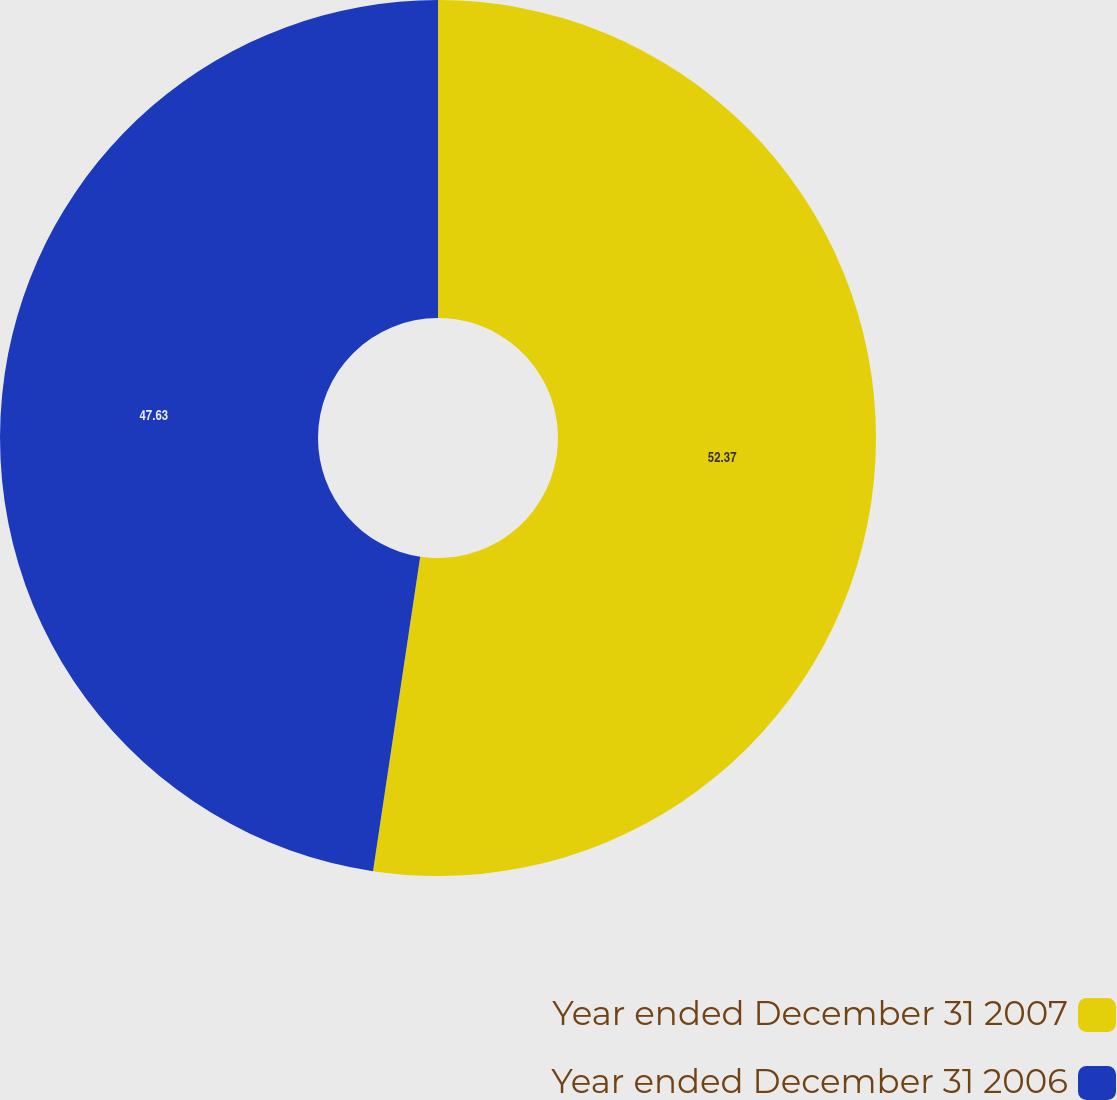Convert chart to OTSL. <chart><loc_0><loc_0><loc_500><loc_500><pie_chart><fcel>Year ended December 31 2007<fcel>Year ended December 31 2006<nl><fcel>52.37%<fcel>47.63%<nl></chart> 